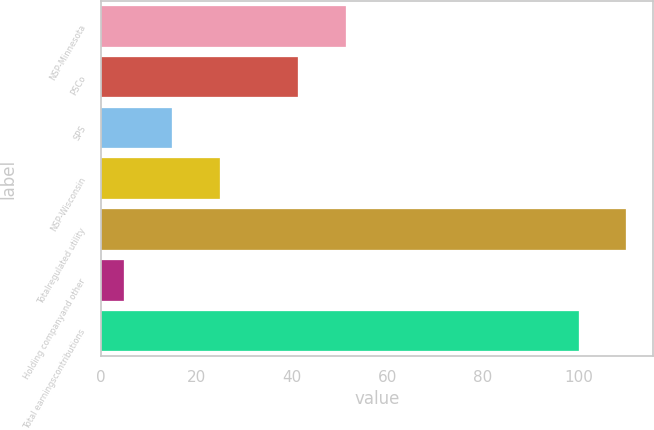Convert chart. <chart><loc_0><loc_0><loc_500><loc_500><bar_chart><fcel>NSP-Minnesota<fcel>PSCo<fcel>SPS<fcel>NSP-Wisconsin<fcel>Totalregulated utility<fcel>Holding companyand other<fcel>Total earningscontributions<nl><fcel>51.3<fcel>41.3<fcel>14.9<fcel>24.9<fcel>110<fcel>4.9<fcel>100<nl></chart> 